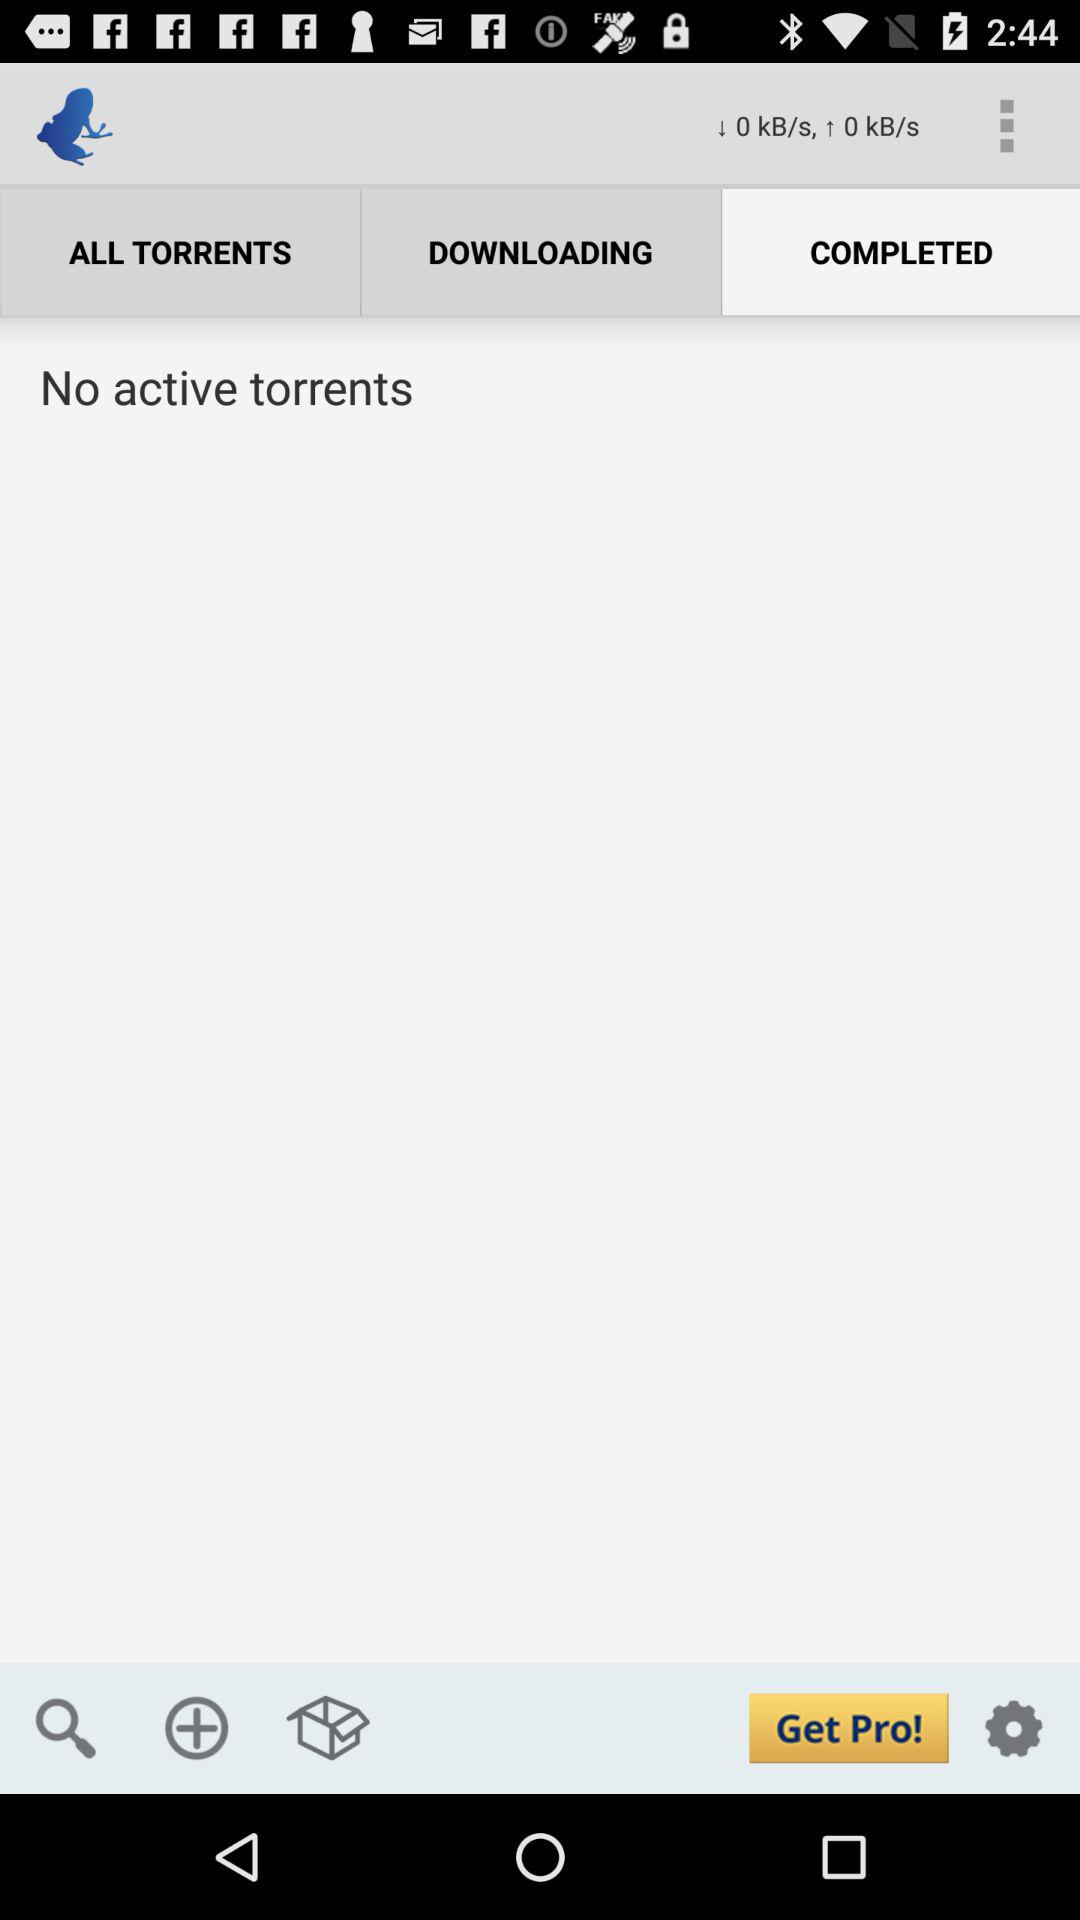Which tab is selected? The selected tab is "COMPLETED". 